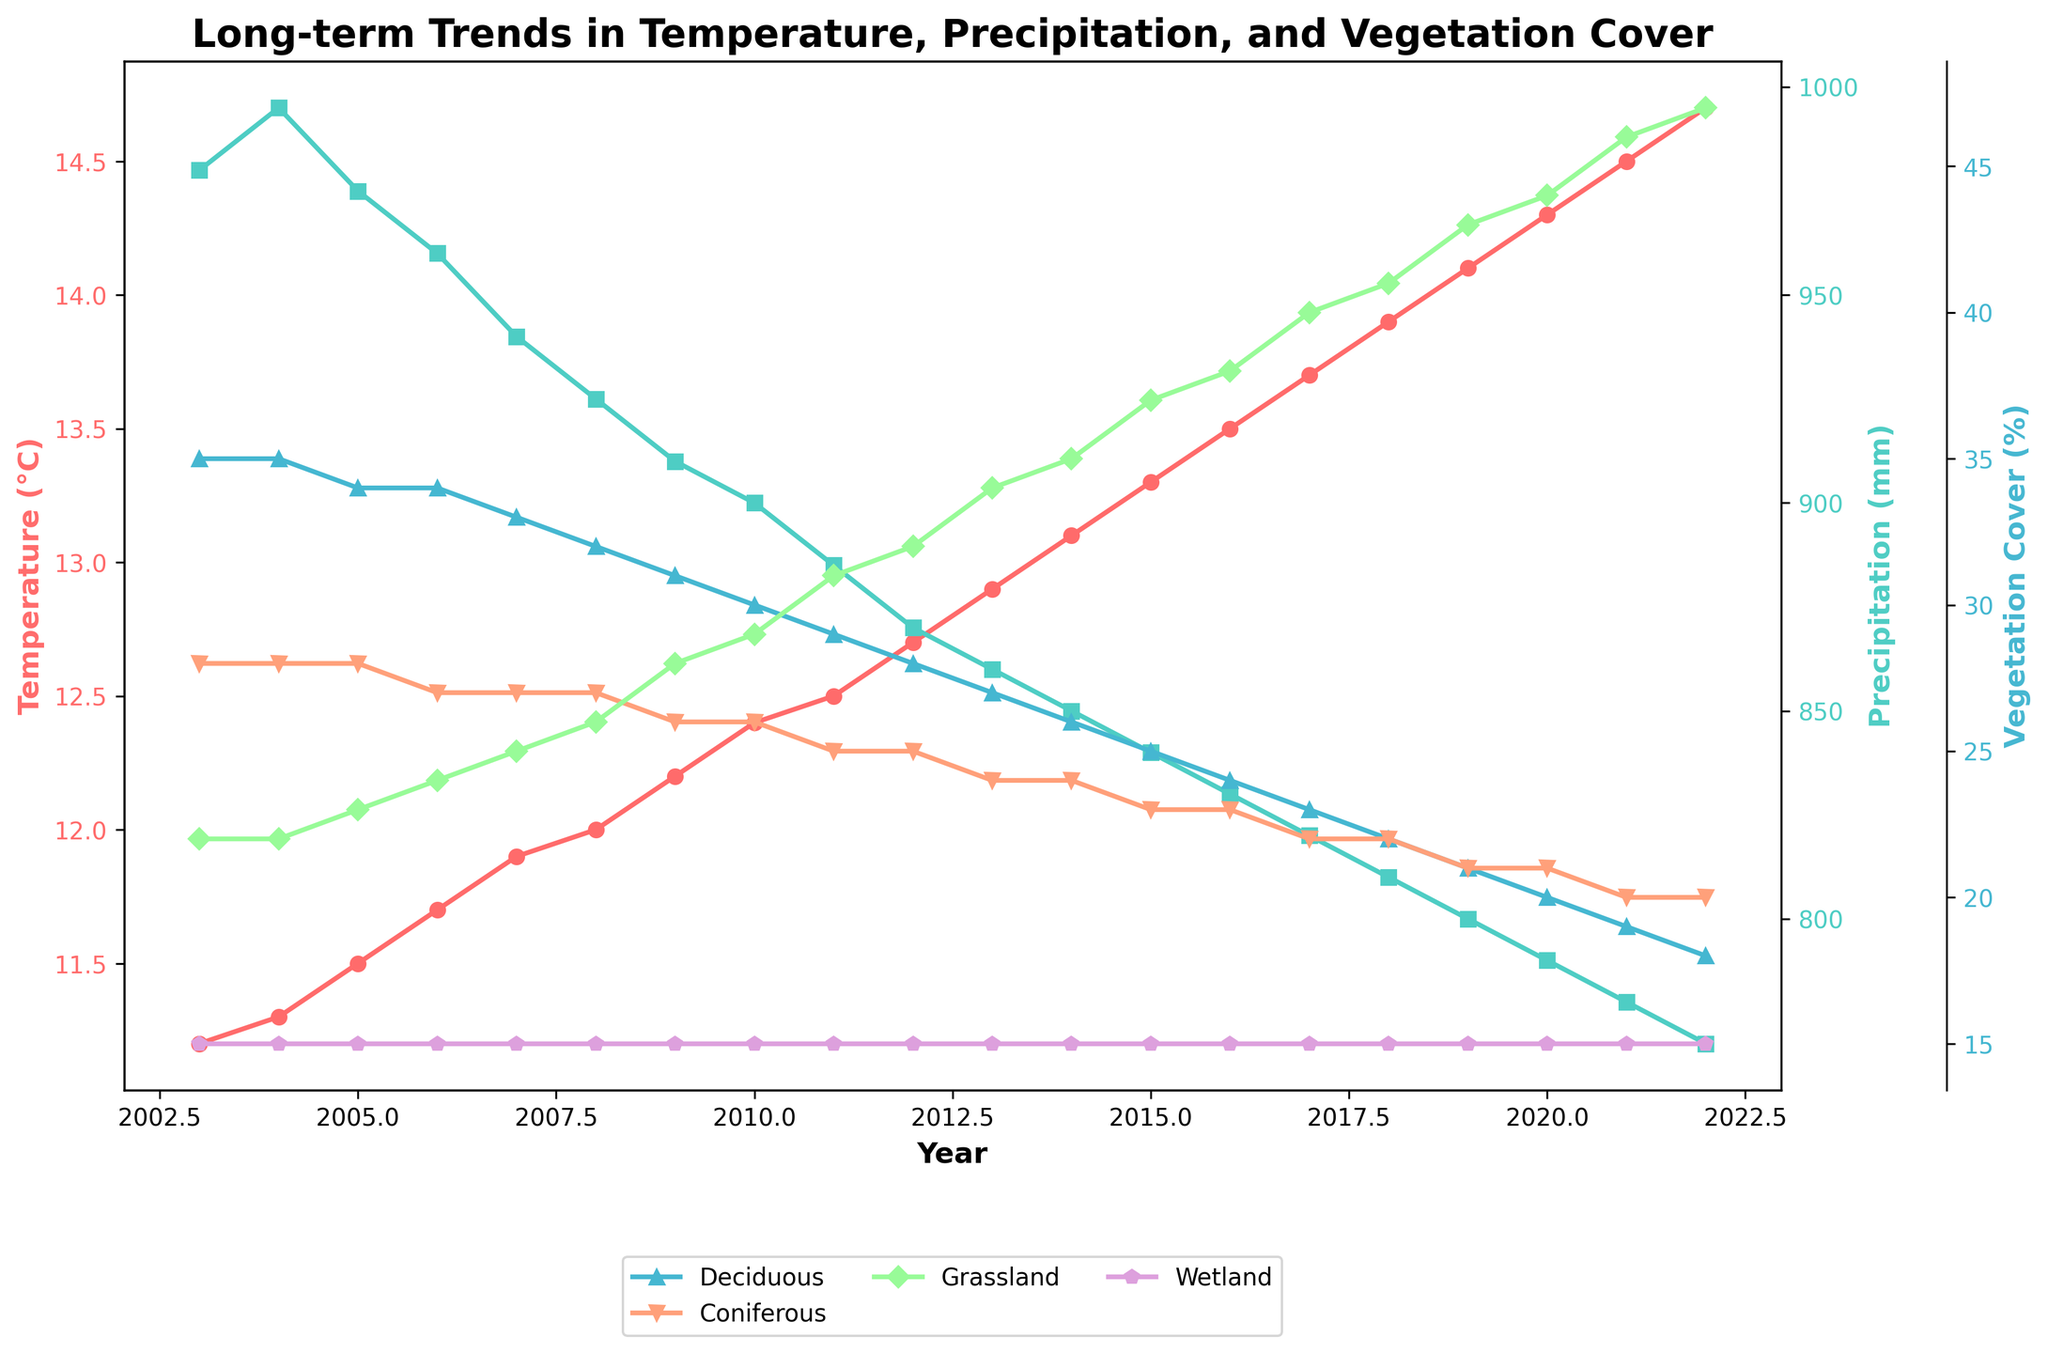What trend do we observe in average temperature over the 20 years? The line representing the average temperature shows a continuous upward trend from 11.2°C in 2003 to 14.7°C in 2022.
Answer: Upward How does the annual precipitation change from 2003 to 2022? The line for annual precipitation shows a continuous decrease from 980 mm in 2003 to 770 mm in 2022.
Answer: Decrease Which year has the highest grassland cover percentage and what is it? Observing the green line representing grassland cover, 2021 has the highest value at 46%.
Answer: 2021, 46% How is the coniferous forest cover trend similar to or different from the wetland cover trend? The coniferous forest cover shows a slight decrease from 28% in 2003 to 20% in 2022, while wetland cover remains constant at 15% throughout the 20 years.
Answer: Coniferous forest cover decreases while wetland cover remains constant What's the difference in average temperature between the years 2003 and 2022? In 2003, the average temperature was 11.2°C, and in 2022, it was 14.7°C. So, the difference is 14.7 - 11.2 = 3.5°C.
Answer: 3.5°C How does the vegetation cover for deciduous forests change over 20 years? The blue line for deciduous forest cover shows a decrease from 35% in 2003 to 18% in 2022.
Answer: Decrease Which two vegetation types had the most significant changes in their cover percentages? Grassland cover increased from 22% in 2003 to 47% in 2022 (largest increase), and deciduous forest cover decreased from 35% to 18% (largest decrease).
Answer: Grassland (most increase), Deciduous (most decrease) Is the annual precipitation in 2010 higher or lower than in 2009? The cyan line for annual precipitation shows a value of 900 mm in 2010, which is lower than 910 mm in 2009.
Answer: Lower Average out the deciduous forest cover for 2003 and 2022. What is the result? The deciduous forest cover was 35% in 2003 and 18% in 2022. The average is (35 + 18) / 2 = 26.5%.
Answer: 26.5% 